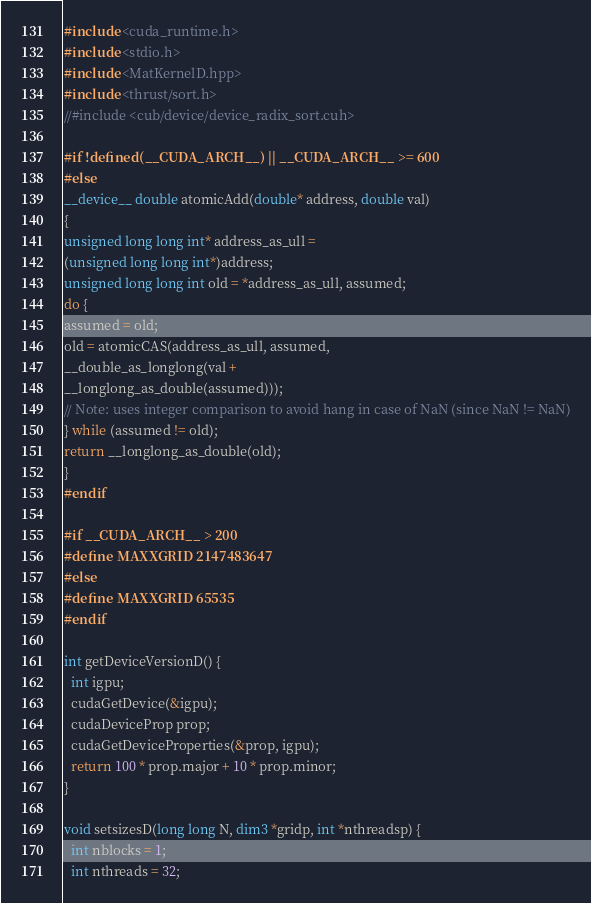<code> <loc_0><loc_0><loc_500><loc_500><_Cuda_>#include <cuda_runtime.h>
#include <stdio.h>
#include <MatKernelD.hpp>
#include <thrust/sort.h>
//#include <cub/device/device_radix_sort.cuh>

#if !defined(__CUDA_ARCH__) || __CUDA_ARCH__ >= 600
#else
__device__ double atomicAdd(double* address, double val)
{
unsigned long long int* address_as_ull =
(unsigned long long int*)address;
unsigned long long int old = *address_as_ull, assumed;
do {
assumed = old;
old = atomicCAS(address_as_ull, assumed,
__double_as_longlong(val +
__longlong_as_double(assumed)));
// Note: uses integer comparison to avoid hang in case of NaN (since NaN != NaN)
} while (assumed != old);
return __longlong_as_double(old);
}
#endif

#if __CUDA_ARCH__ > 200
#define MAXXGRID 2147483647
#else
#define MAXXGRID 65535
#endif

int getDeviceVersionD() {
  int igpu;
  cudaGetDevice(&igpu);
  cudaDeviceProp prop;
  cudaGetDeviceProperties(&prop, igpu);
  return 100 * prop.major + 10 * prop.minor;
}

void setsizesD(long long N, dim3 *gridp, int *nthreadsp) {
  int nblocks = 1;
  int nthreads = 32;</code> 